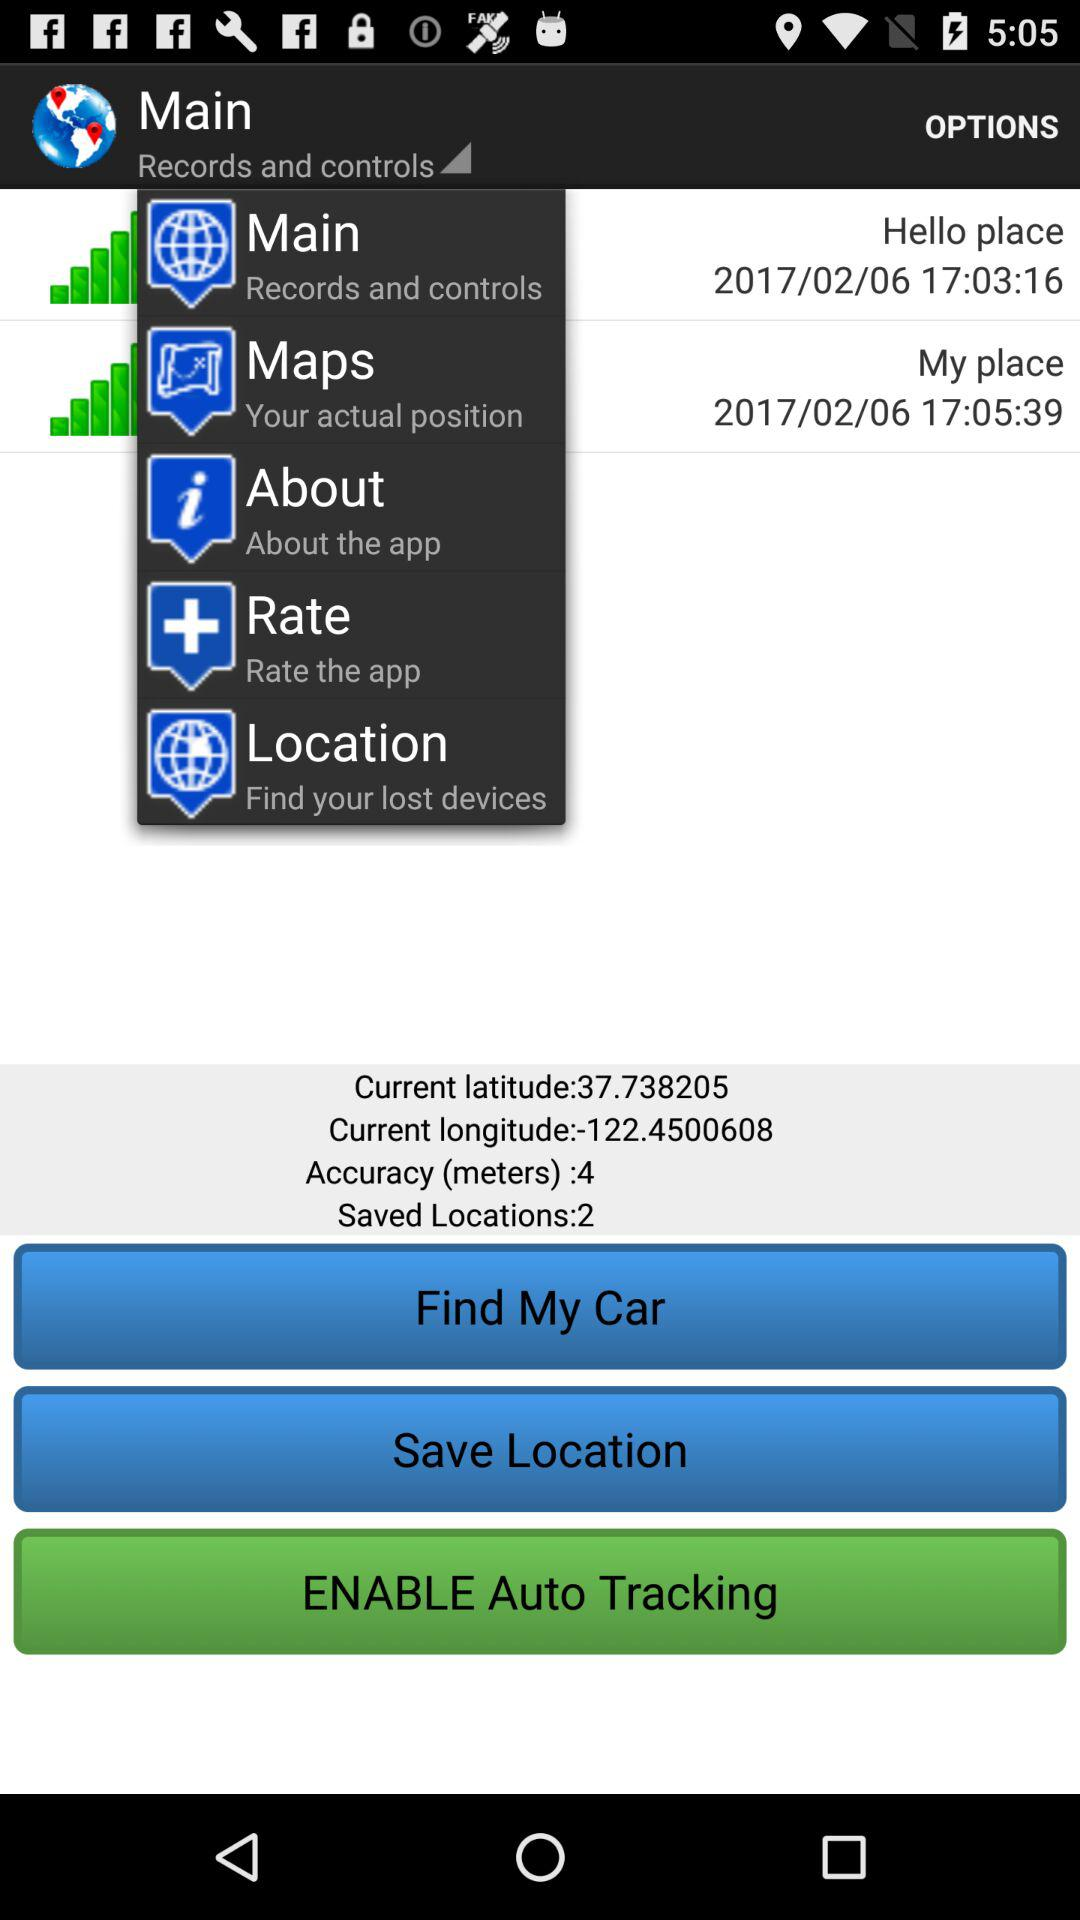How many locations have been saved? The locations that have been saved are 2. 